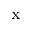<formula> <loc_0><loc_0><loc_500><loc_500>_ { x }</formula> 